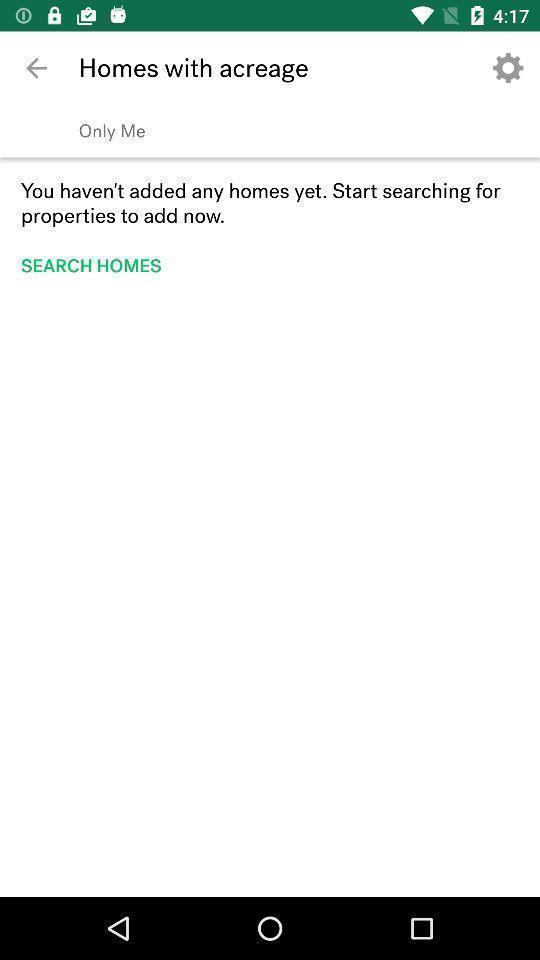What details can you identify in this image? Search option page in a property finding app. 